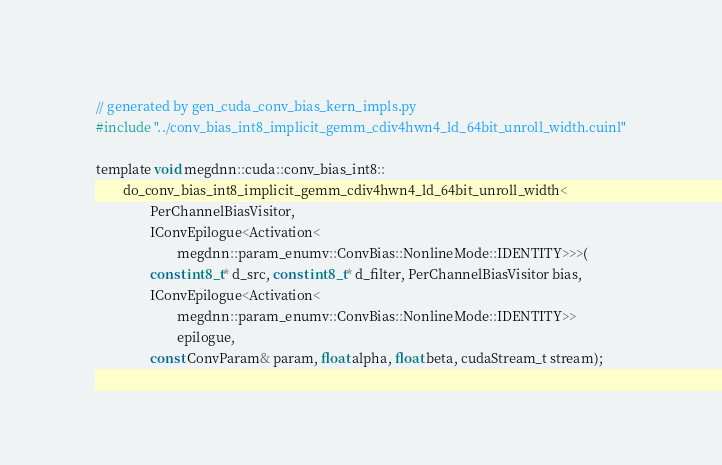Convert code to text. <code><loc_0><loc_0><loc_500><loc_500><_Cuda_>// generated by gen_cuda_conv_bias_kern_impls.py
#include "../conv_bias_int8_implicit_gemm_cdiv4hwn4_ld_64bit_unroll_width.cuinl"

template void megdnn::cuda::conv_bias_int8::
        do_conv_bias_int8_implicit_gemm_cdiv4hwn4_ld_64bit_unroll_width<
                PerChannelBiasVisitor,
                IConvEpilogue<Activation<
                        megdnn::param_enumv::ConvBias::NonlineMode::IDENTITY>>>(
                const int8_t* d_src, const int8_t* d_filter, PerChannelBiasVisitor bias,
                IConvEpilogue<Activation<
                        megdnn::param_enumv::ConvBias::NonlineMode::IDENTITY>>
                        epilogue,
                const ConvParam& param, float alpha, float beta, cudaStream_t stream);
</code> 